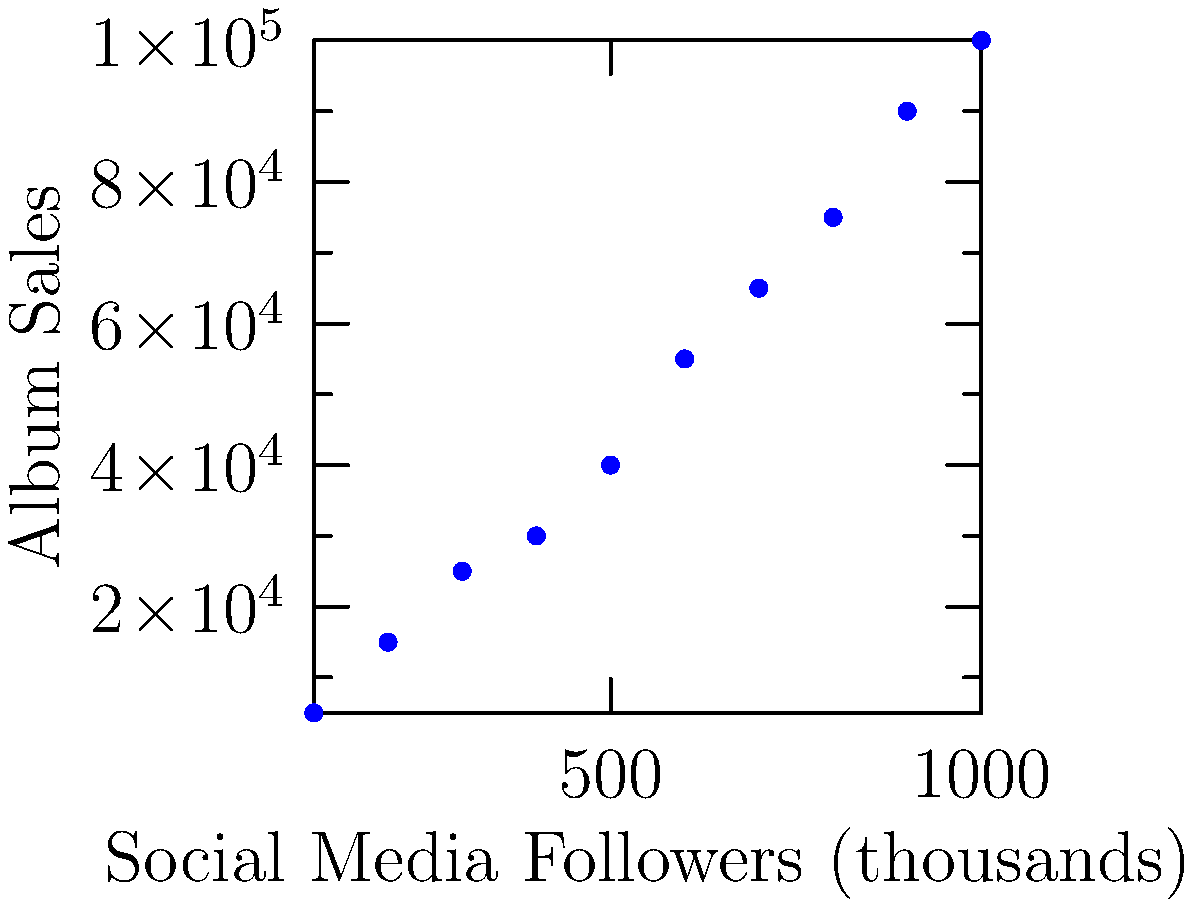As the CEO of a prominent record label, you're analyzing the relationship between an artist's social media following and their album sales. The scatter plot shows data from 10 different artists, with social media followers (in thousands) on the x-axis and album sales on the y-axis. What conclusion can you draw about the correlation between social media followers and album sales, and how might this inform your marketing strategy? To answer this question, we need to analyze the scatter plot and interpret the relationship between social media followers and album sales:

1. Observe the overall trend: The data points generally move from the bottom-left to the top-right of the graph, indicating a positive relationship.

2. Look at the trend line: The red line represents the best-fit linear trend, which clearly shows an upward slope.

3. Assess the strength of the correlation: The data points are relatively close to the trend line, suggesting a strong positive correlation.

4. Interpret the correlation: As social media followers increase, album sales tend to increase as well.

5. Consider outliers: There don't appear to be significant outliers that would skew the relationship.

6. Quantify the relationship: For every 100,000 increase in social media followers, there's roughly a 10,000-15,000 increase in album sales (estimated from the graph).

7. Marketing strategy implications:
   a) Invest in growing artists' social media presence
   b) Target marketing efforts on platforms where artists have the largest followings
   c) Use social media metrics as a predictor of potential album sales
   d) Allocate more resources to artists with larger social media followings

8. Remember correlation ≠ causation: While there's a strong relationship, other factors may influence both variables.
Answer: Strong positive correlation; invest in growing artists' social media presence to potentially increase album sales. 